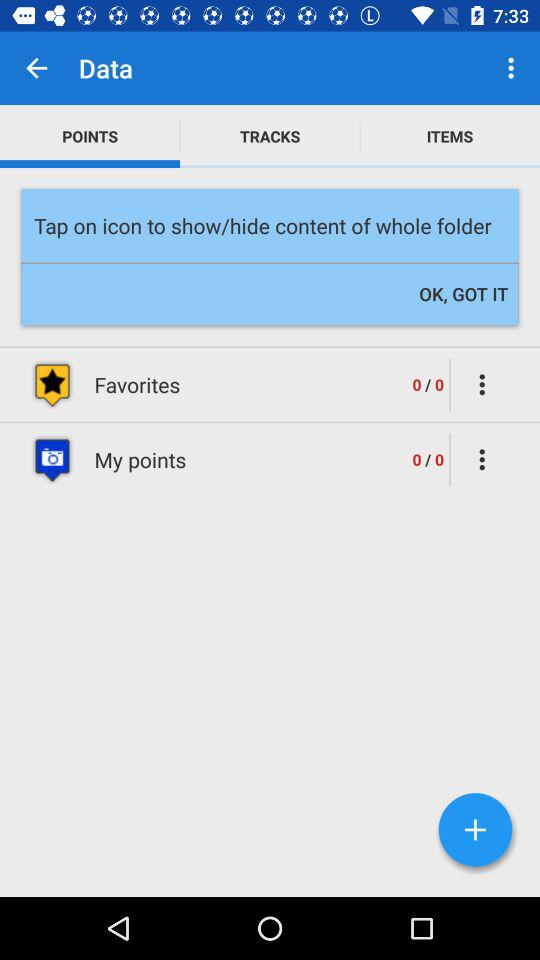What is the selected option? The selected option is "POINTS". 